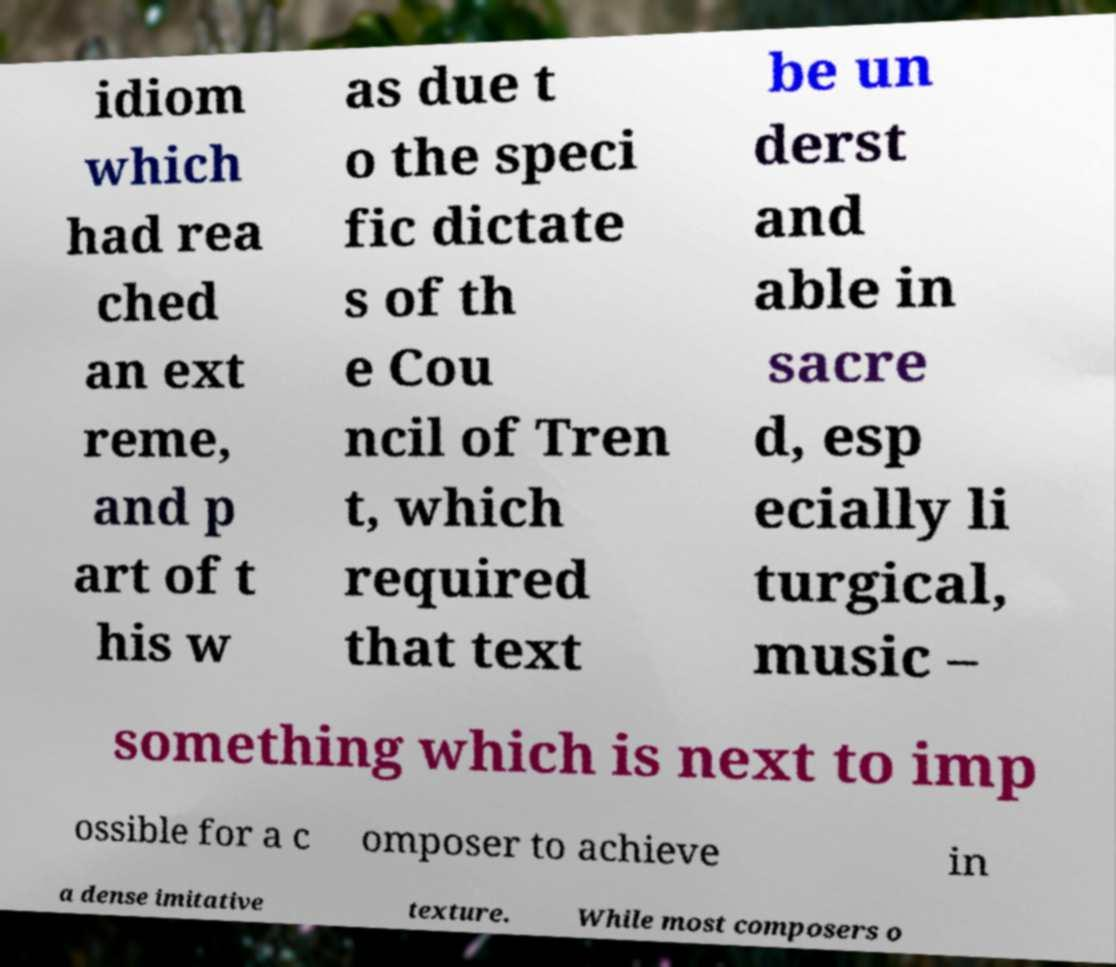What messages or text are displayed in this image? I need them in a readable, typed format. idiom which had rea ched an ext reme, and p art of t his w as due t o the speci fic dictate s of th e Cou ncil of Tren t, which required that text be un derst and able in sacre d, esp ecially li turgical, music – something which is next to imp ossible for a c omposer to achieve in a dense imitative texture. While most composers o 